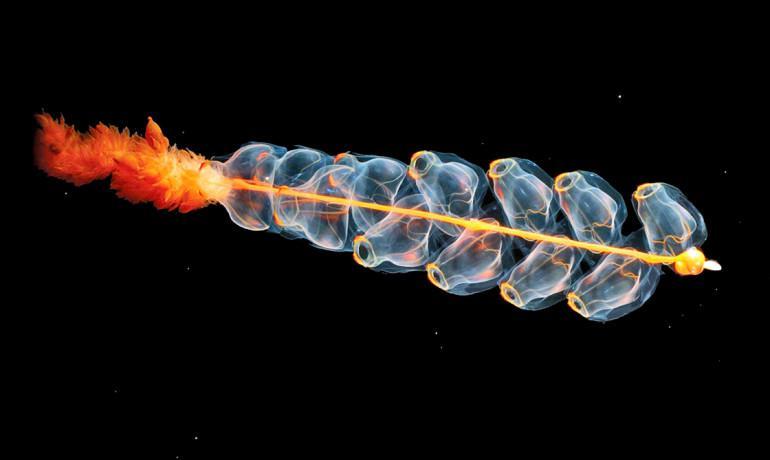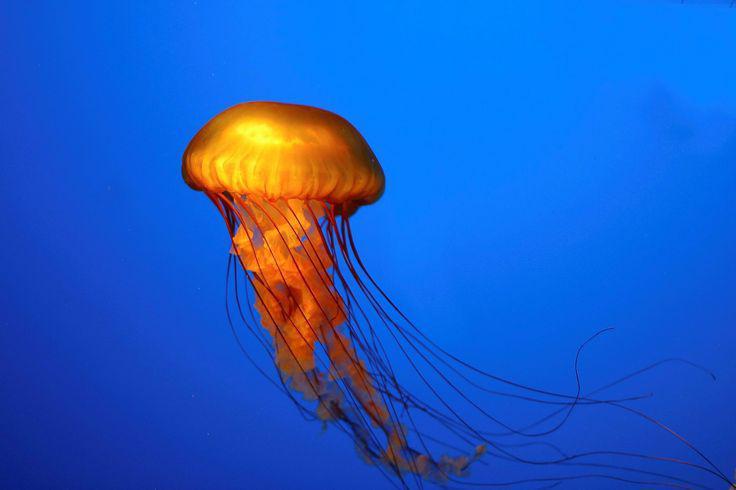The first image is the image on the left, the second image is the image on the right. For the images shown, is this caption "There is a warm-coloured jellyfish in the right image with a darker blue almost solid water background." true? Answer yes or no. Yes. 